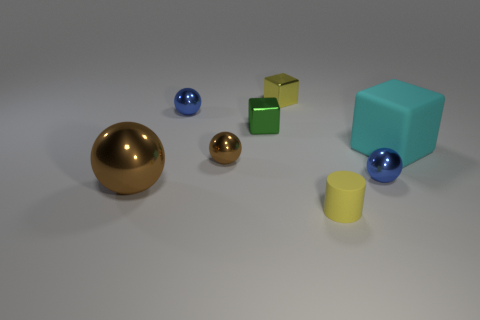Add 1 spheres. How many objects exist? 9 Subtract all blocks. How many objects are left? 5 Subtract 0 purple balls. How many objects are left? 8 Subtract all big rubber objects. Subtract all large matte objects. How many objects are left? 6 Add 2 small yellow metal objects. How many small yellow metal objects are left? 3 Add 2 small red balls. How many small red balls exist? 2 